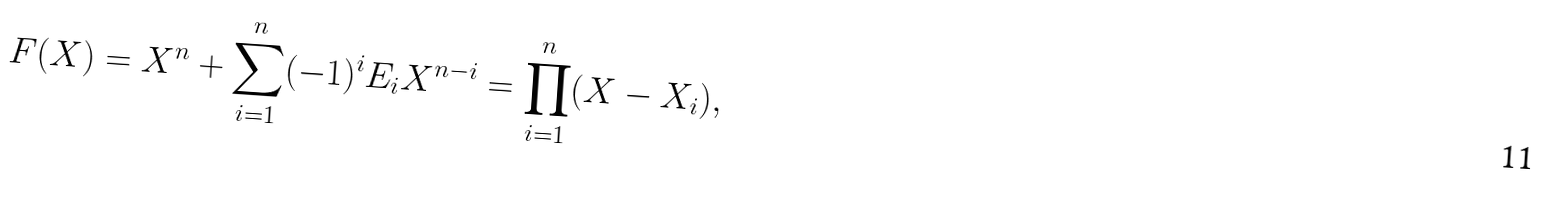Convert formula to latex. <formula><loc_0><loc_0><loc_500><loc_500>F ( X ) = X ^ { n } + \sum _ { i = 1 } ^ { n } ( - 1 ) ^ { i } E _ { i } X ^ { n - i } = \prod _ { i = 1 } ^ { n } ( X - X _ { i } ) ,</formula> 